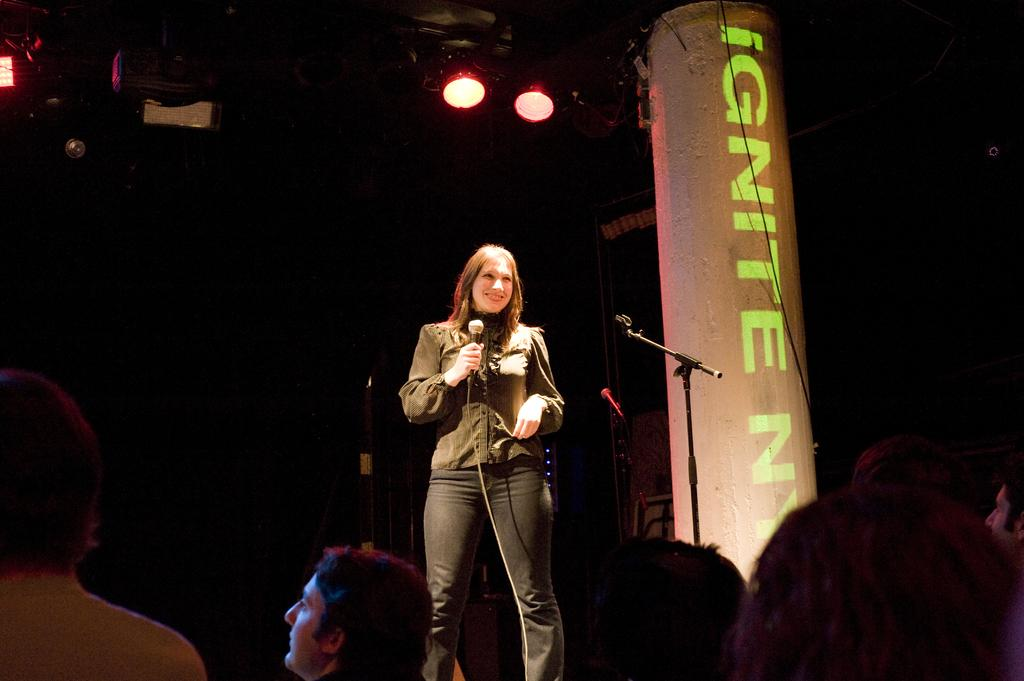Who is the main subject in the image? There is a woman in the image. Where is the woman located in the image? The woman is standing on a stage. What is the woman holding in her hands? The woman is holding a microphone in her hands. What can be seen in the background of the image? There are show lights visible in the image. What color is the yarn used to create the woman's shoes in the image? There is no yarn or mention of shoes in the image; the woman is holding a microphone and standing on a stage. 